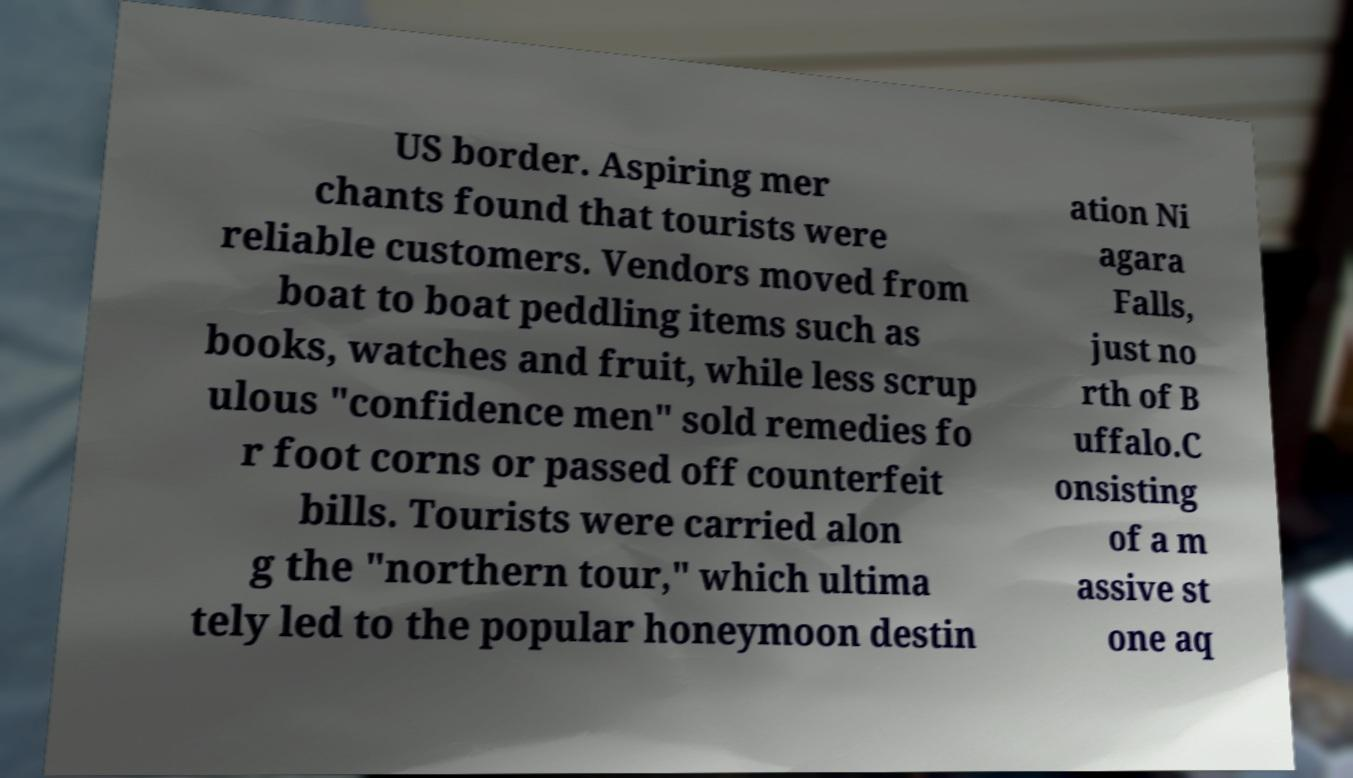Please identify and transcribe the text found in this image. US border. Aspiring mer chants found that tourists were reliable customers. Vendors moved from boat to boat peddling items such as books, watches and fruit, while less scrup ulous "confidence men" sold remedies fo r foot corns or passed off counterfeit bills. Tourists were carried alon g the "northern tour," which ultima tely led to the popular honeymoon destin ation Ni agara Falls, just no rth of B uffalo.C onsisting of a m assive st one aq 